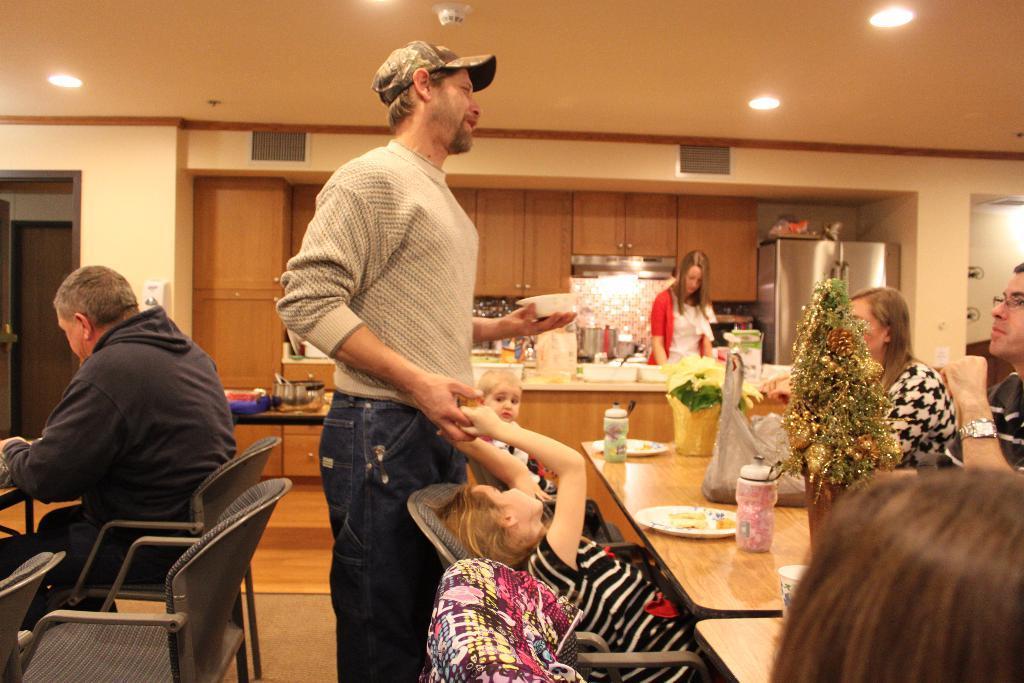Can you describe this image briefly? In this picture there are group of people those who are sitting around the table and there is dining table, there is a person who is standing at the center of the image, who is holding the hands of a girl who is sitting on the chair, there is a flower pot on the table, it seems to be a hotel. 